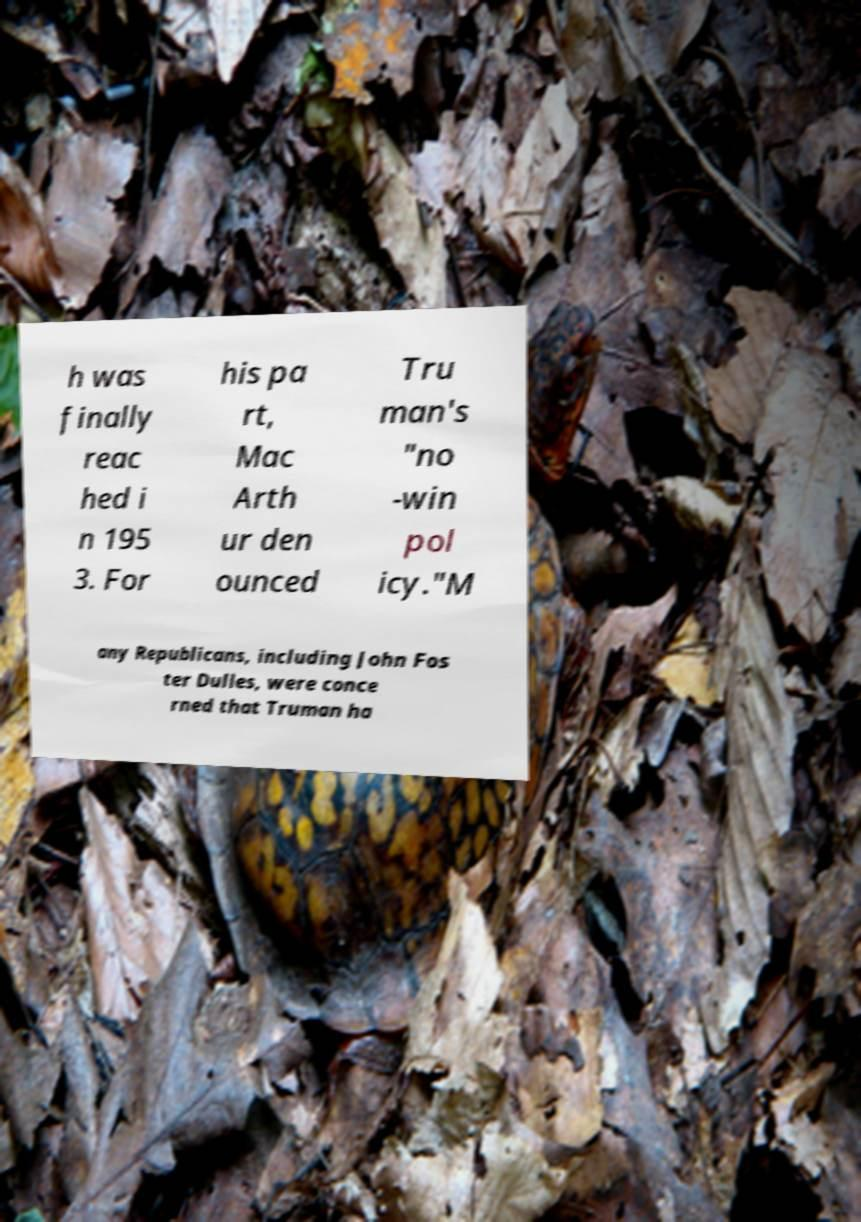Could you assist in decoding the text presented in this image and type it out clearly? h was finally reac hed i n 195 3. For his pa rt, Mac Arth ur den ounced Tru man's "no -win pol icy."M any Republicans, including John Fos ter Dulles, were conce rned that Truman ha 